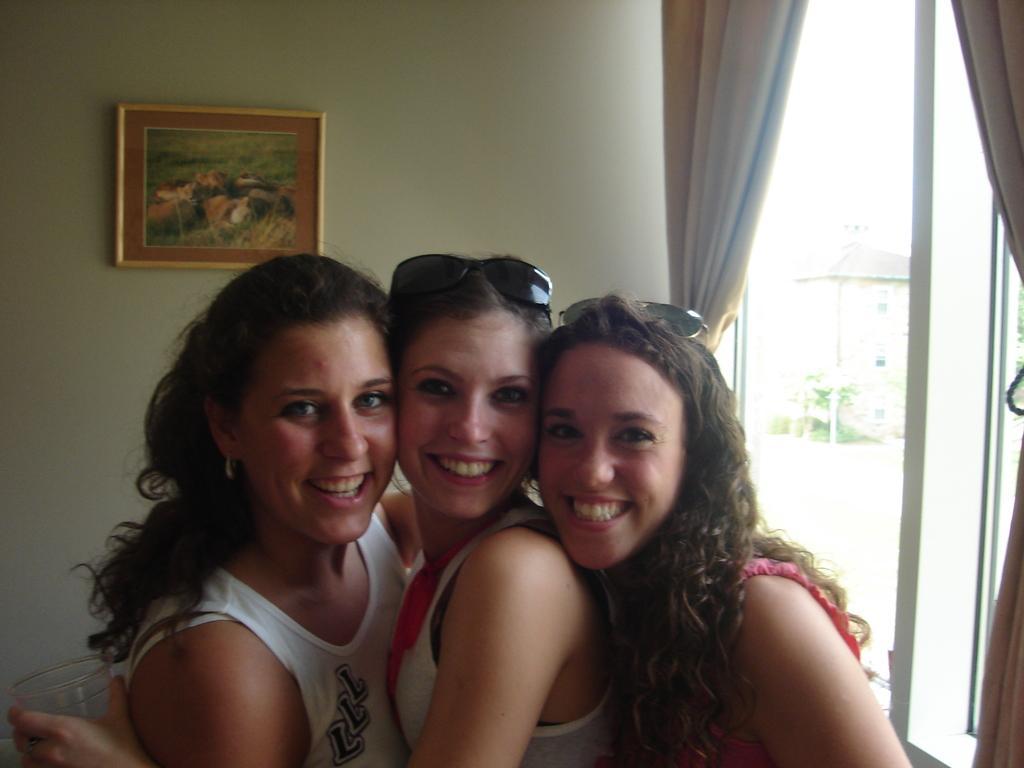Could you give a brief overview of what you see in this image? In this picture, we see three women are standing and they are smiling. They are posing for the photo. The woman in the middle is holding a glass in her hand. Behind them, we see a white wall on which a photo frame is placed. On the right side, we see the curtains and the glass windows from which we can see the trees and the buildings. 